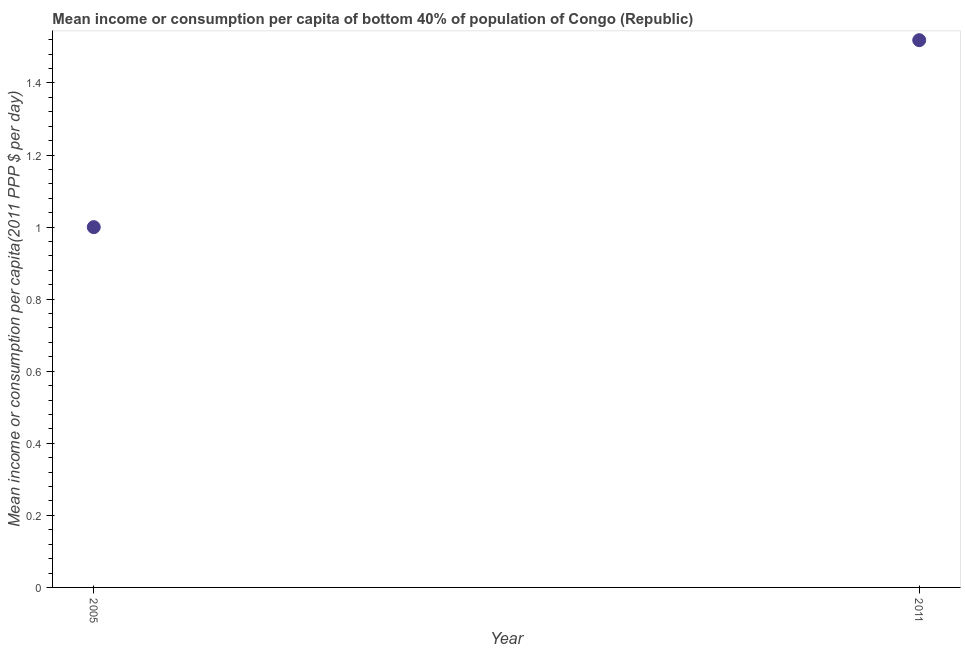What is the mean income or consumption in 2011?
Make the answer very short. 1.52. Across all years, what is the maximum mean income or consumption?
Provide a succinct answer. 1.52. Across all years, what is the minimum mean income or consumption?
Offer a very short reply. 1. In which year was the mean income or consumption maximum?
Ensure brevity in your answer.  2011. In which year was the mean income or consumption minimum?
Offer a very short reply. 2005. What is the sum of the mean income or consumption?
Provide a succinct answer. 2.52. What is the difference between the mean income or consumption in 2005 and 2011?
Provide a succinct answer. -0.52. What is the average mean income or consumption per year?
Offer a very short reply. 1.26. What is the median mean income or consumption?
Offer a terse response. 1.26. Do a majority of the years between 2011 and 2005 (inclusive) have mean income or consumption greater than 0.04 $?
Offer a very short reply. No. What is the ratio of the mean income or consumption in 2005 to that in 2011?
Give a very brief answer. 0.66. Is the mean income or consumption in 2005 less than that in 2011?
Make the answer very short. Yes. Does the mean income or consumption monotonically increase over the years?
Make the answer very short. Yes. How many dotlines are there?
Your answer should be very brief. 1. What is the difference between two consecutive major ticks on the Y-axis?
Offer a very short reply. 0.2. Does the graph contain grids?
Ensure brevity in your answer.  No. What is the title of the graph?
Your answer should be very brief. Mean income or consumption per capita of bottom 40% of population of Congo (Republic). What is the label or title of the X-axis?
Your answer should be very brief. Year. What is the label or title of the Y-axis?
Keep it short and to the point. Mean income or consumption per capita(2011 PPP $ per day). What is the Mean income or consumption per capita(2011 PPP $ per day) in 2005?
Your answer should be compact. 1. What is the Mean income or consumption per capita(2011 PPP $ per day) in 2011?
Make the answer very short. 1.52. What is the difference between the Mean income or consumption per capita(2011 PPP $ per day) in 2005 and 2011?
Your answer should be compact. -0.52. What is the ratio of the Mean income or consumption per capita(2011 PPP $ per day) in 2005 to that in 2011?
Your answer should be very brief. 0.66. 